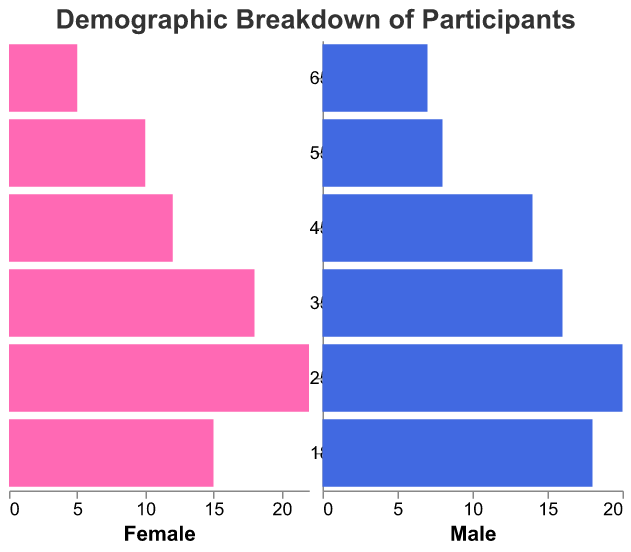How are the age groups ordered in the population pyramid? The bars in the population pyramid are ordered by age group from top to bottom, starting with "65+" at the top and ending with "18-24" at the bottom.
Answer: From oldest to youngest Which age group has the highest number of female participants? Observing the left side of the population pyramid, the largest negative bar corresponds to the age group "25-34" with 22 female participants.
Answer: 25-34 How many participants in total are there in the "35-44" age group? Adding the number of female (18) and male (16) participants together: 18 + 16 = 34.
Answer: 34 What is the education level of participants in the "55-64" age group? For the "55-64" age group, the education level displayed in the tooltip for both male and female bars is "High School."
Answer: High School Which age group has more male participants than female participants? Comparing the lengths of the bars on each side, the "18-24" and "65+" age groups have males outnumbering females.
Answer: 18-24 and 65+ In which age group is the number of male participants exactly equal to the number of female participants? No age group has the same number of male and female participants. Each age group shows a different number for males and females.
Answer: None What's the difference in the number of female participants between the "18-24" and "55-64" age groups? Subtract the number of female participants in the "55-64" age group (10) from the number in the "18-24" age group (15): 15 - 10 = 5.
Answer: 5 How many total participants have a Bachelor's degree across all age groups? Sum the number of participants with a Bachelor's degree: (25-34: 22F + 20M) + (45-54: 12F + 14M) = 42 + 26 = 68.
Answer: 68 Which age group has the lowest number of total participants? Adding females and males together for each age group, the "65+" age group has the lowest total: 5 (Female) + 7 (Male) = 12.
Answer: 65+ What is the average number of female participants across all age groups? Summing female participants and dividing by the number of age groups: (15 + 22 + 18 + 12 + 10 + 5) / 6 = 82 / 6 ≈ 13.67.
Answer: 13.67 